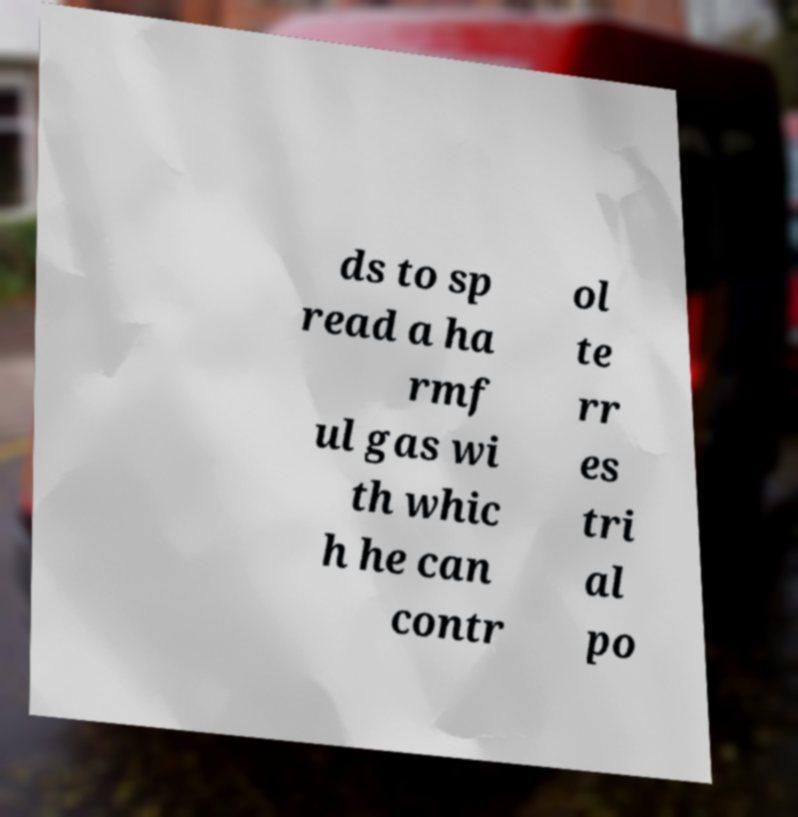Could you assist in decoding the text presented in this image and type it out clearly? ds to sp read a ha rmf ul gas wi th whic h he can contr ol te rr es tri al po 